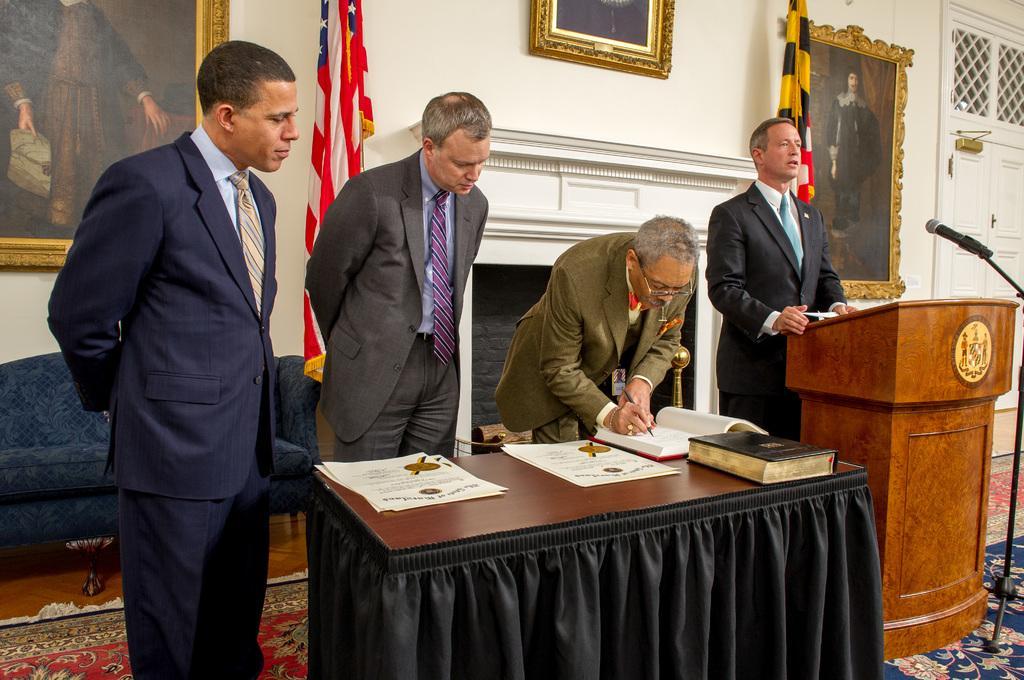Can you describe this image briefly? In this image, In the middle there is a table of brown color and the table is covered by a black color cloth on the right side there is a brown color wooden block and there is a black color microphone and there are some people standing and in the background there is a white color wall and there are some poster in yellow color. 